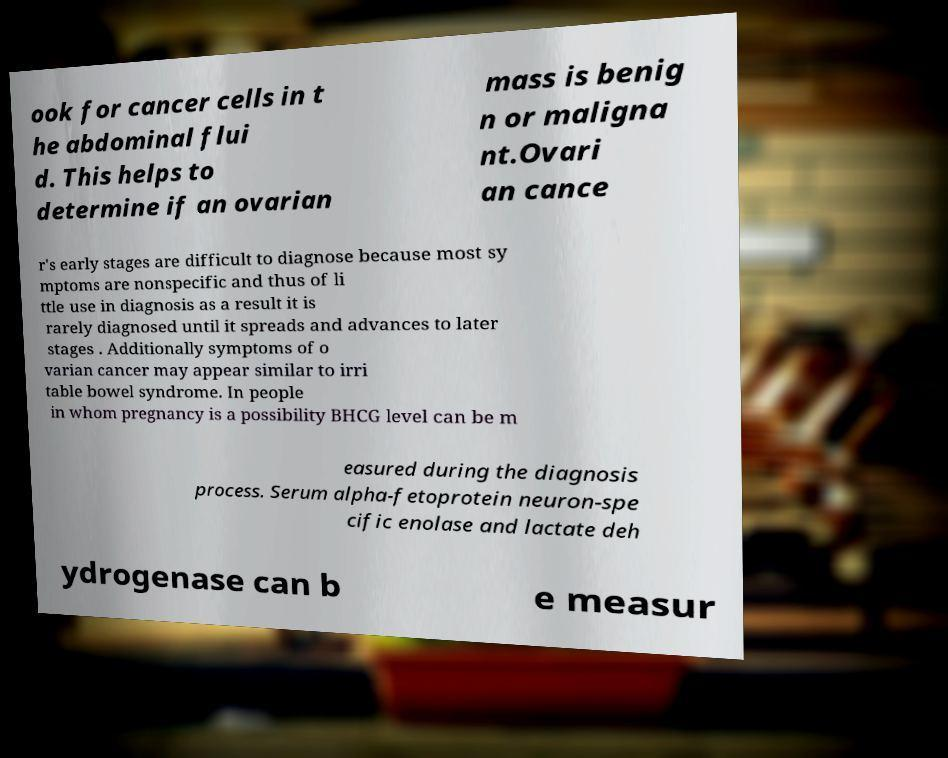Could you assist in decoding the text presented in this image and type it out clearly? ook for cancer cells in t he abdominal flui d. This helps to determine if an ovarian mass is benig n or maligna nt.Ovari an cance r's early stages are difficult to diagnose because most sy mptoms are nonspecific and thus of li ttle use in diagnosis as a result it is rarely diagnosed until it spreads and advances to later stages . Additionally symptoms of o varian cancer may appear similar to irri table bowel syndrome. In people in whom pregnancy is a possibility BHCG level can be m easured during the diagnosis process. Serum alpha-fetoprotein neuron-spe cific enolase and lactate deh ydrogenase can b e measur 